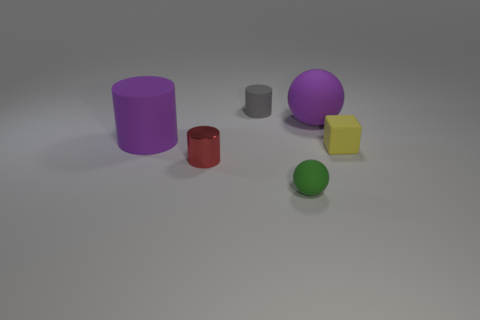There is an object that is both in front of the tiny yellow object and to the right of the tiny metal cylinder; what is its color? The object you're referring to is the green sphere. It's situated ahead of the small yellow cube and to the right of the small grey cylinder when viewed from your current perspective. 